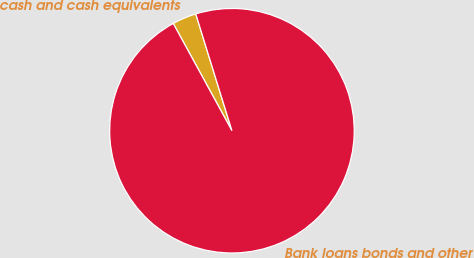Convert chart. <chart><loc_0><loc_0><loc_500><loc_500><pie_chart><fcel>cash and cash equivalents<fcel>Bank loans bonds and other<nl><fcel>3.19%<fcel>96.81%<nl></chart> 